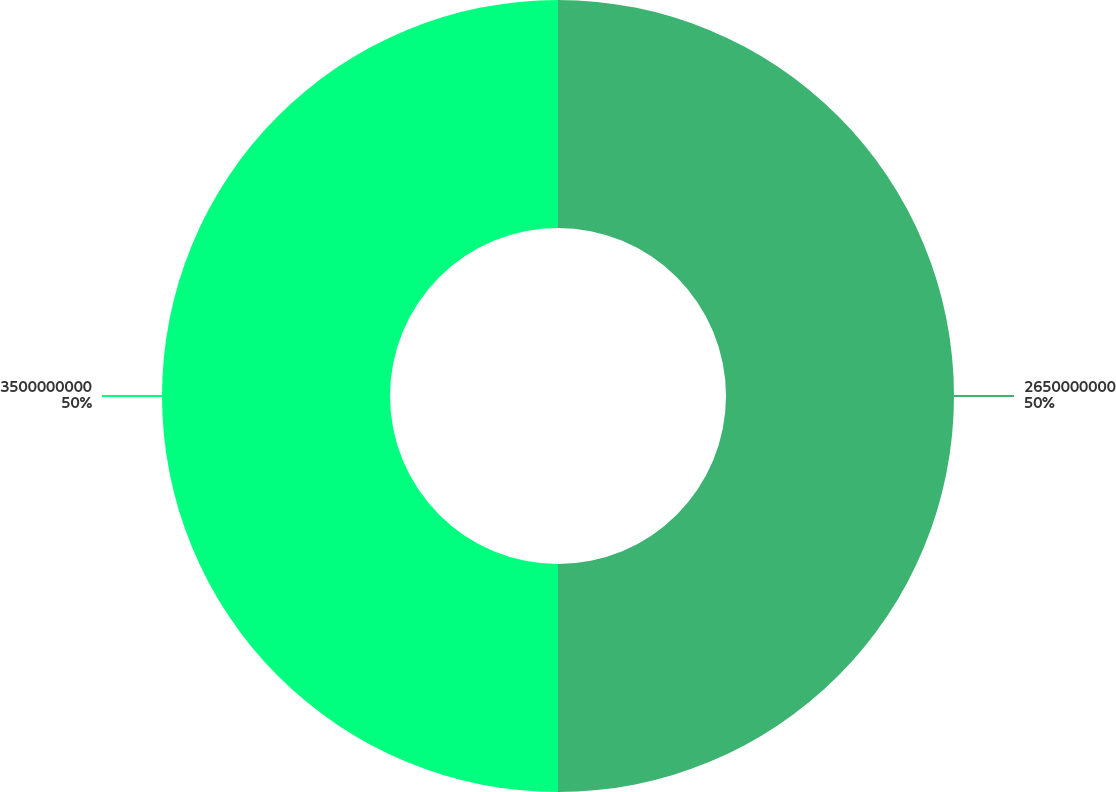<chart> <loc_0><loc_0><loc_500><loc_500><pie_chart><fcel>2650000000<fcel>3500000000<nl><fcel>50.0%<fcel>50.0%<nl></chart> 